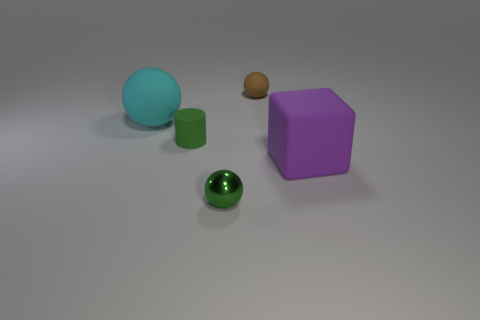There is a tiny green thing that is the same shape as the tiny brown rubber thing; what is its material?
Your response must be concise. Metal. What number of other objects are there of the same size as the shiny ball?
Offer a very short reply. 2. What is the shape of the small matte thing that is behind the large thing on the left side of the small brown sphere that is to the right of the green cylinder?
Offer a terse response. Sphere. There is a matte thing that is both in front of the brown rubber ball and right of the small green metal object; what is its shape?
Keep it short and to the point. Cube. How many things are brown things or large rubber things to the right of the cyan ball?
Make the answer very short. 2. Do the large ball and the small green cylinder have the same material?
Your response must be concise. Yes. How many other things are there of the same shape as the green rubber object?
Give a very brief answer. 0. There is a rubber object that is right of the green cylinder and in front of the cyan sphere; how big is it?
Provide a short and direct response. Large. How many rubber objects are either green things or big cubes?
Offer a terse response. 2. Do the small thing that is behind the large cyan object and the tiny green object that is in front of the big purple matte cube have the same shape?
Make the answer very short. Yes. 